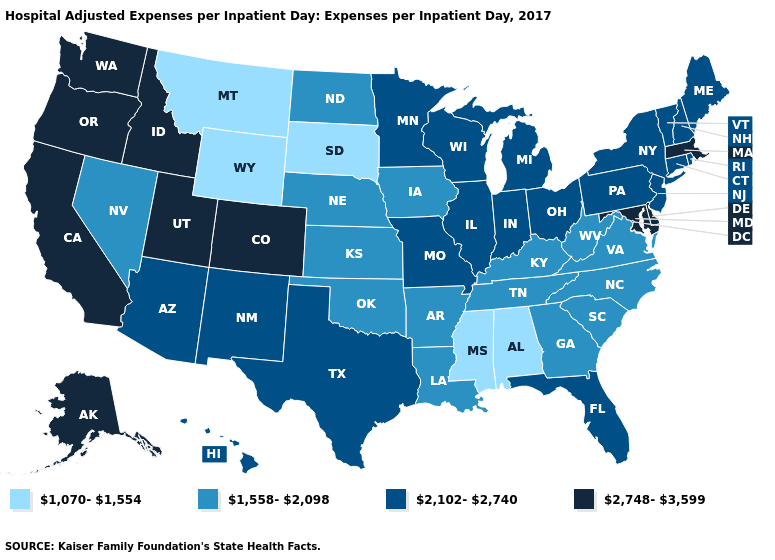Does Oregon have the lowest value in the West?
Short answer required. No. Among the states that border Montana , does Wyoming have the lowest value?
Concise answer only. Yes. Name the states that have a value in the range 2,748-3,599?
Concise answer only. Alaska, California, Colorado, Delaware, Idaho, Maryland, Massachusetts, Oregon, Utah, Washington. Does Montana have the lowest value in the USA?
Give a very brief answer. Yes. What is the value of Nevada?
Give a very brief answer. 1,558-2,098. Among the states that border Indiana , does Michigan have the lowest value?
Keep it brief. No. What is the value of Minnesota?
Keep it brief. 2,102-2,740. Does New Hampshire have a lower value than Maine?
Short answer required. No. What is the highest value in states that border Nevada?
Be succinct. 2,748-3,599. What is the value of Arizona?
Concise answer only. 2,102-2,740. Does North Carolina have a lower value than Wyoming?
Short answer required. No. Name the states that have a value in the range 2,748-3,599?
Quick response, please. Alaska, California, Colorado, Delaware, Idaho, Maryland, Massachusetts, Oregon, Utah, Washington. Name the states that have a value in the range 1,558-2,098?
Short answer required. Arkansas, Georgia, Iowa, Kansas, Kentucky, Louisiana, Nebraska, Nevada, North Carolina, North Dakota, Oklahoma, South Carolina, Tennessee, Virginia, West Virginia. 